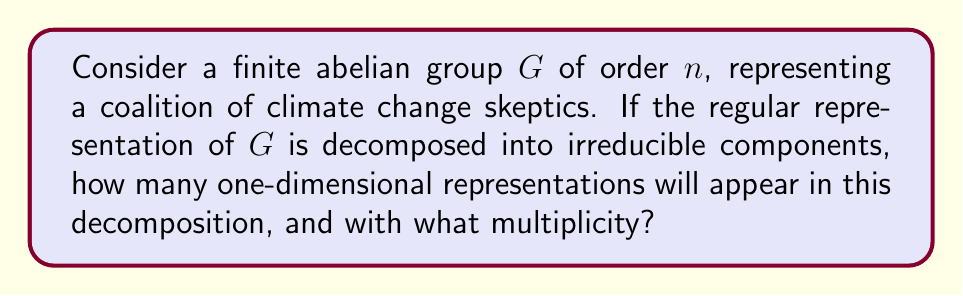Give your solution to this math problem. Let's approach this step-by-step:

1) For a finite abelian group $G$ of order $n$, all irreducible representations are one-dimensional. This is because all subgroups of an abelian group are normal, and thus all irreducible representations are linear characters.

2) The number of irreducible representations of a finite group is equal to the number of conjugacy classes. In an abelian group, each element forms its own conjugacy class. Therefore, the number of irreducible representations is equal to the order of the group, $n$.

3) The regular representation of a finite group $G$ is a representation of dimension $|G| = n$. It can be decomposed into a direct sum of all irreducible representations of $G$, each appearing with multiplicity equal to its dimension.

4) In this case, we have $n$ one-dimensional irreducible representations.

5) The decomposition of the regular representation $R$ can be written as:

   $$R = \bigoplus_{i=1}^n \chi_i$$

   where $\chi_i$ are the irreducible representations (characters) of $G$.

6) Since the dimension of the regular representation is $n$, and we have $n$ one-dimensional representations in the decomposition, each must appear exactly once for the dimensions to match.

Therefore, the regular representation decomposes into $n$ one-dimensional irreducible representations, each with multiplicity 1.
Answer: $n$ one-dimensional representations, each with multiplicity 1 